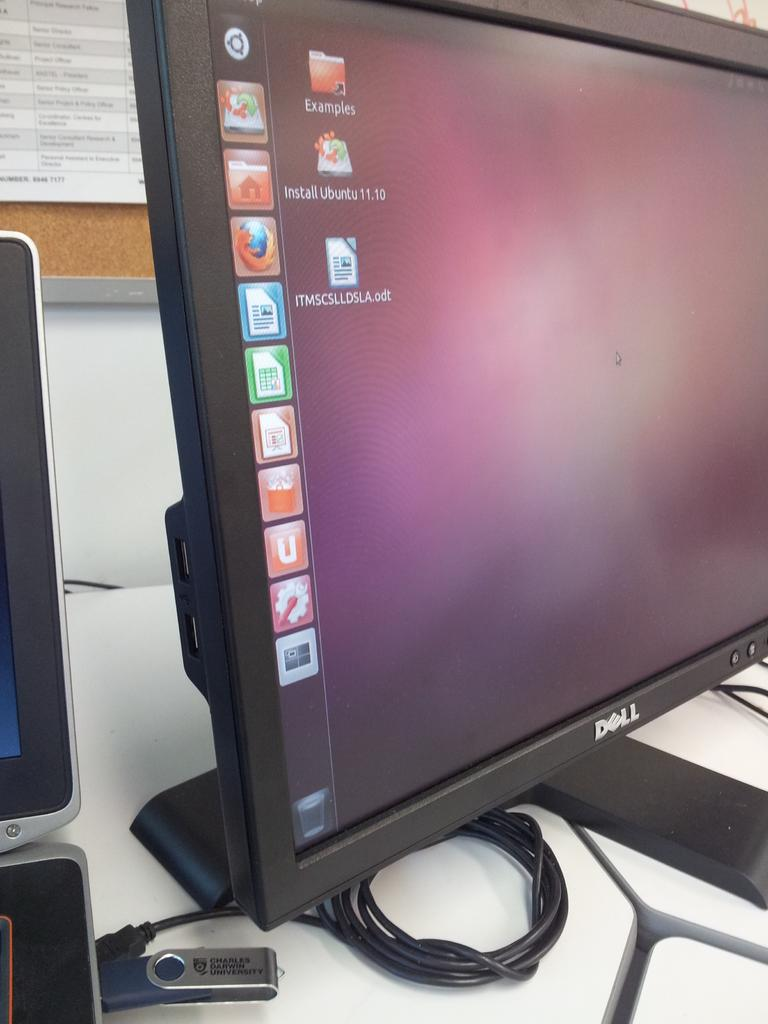<image>
Describe the image concisely. A DELL brand computer monitor is shown from a side view with icons,  and EXAMPLES folder and a document ITMSCSLLDSLA.odt on the screen. 